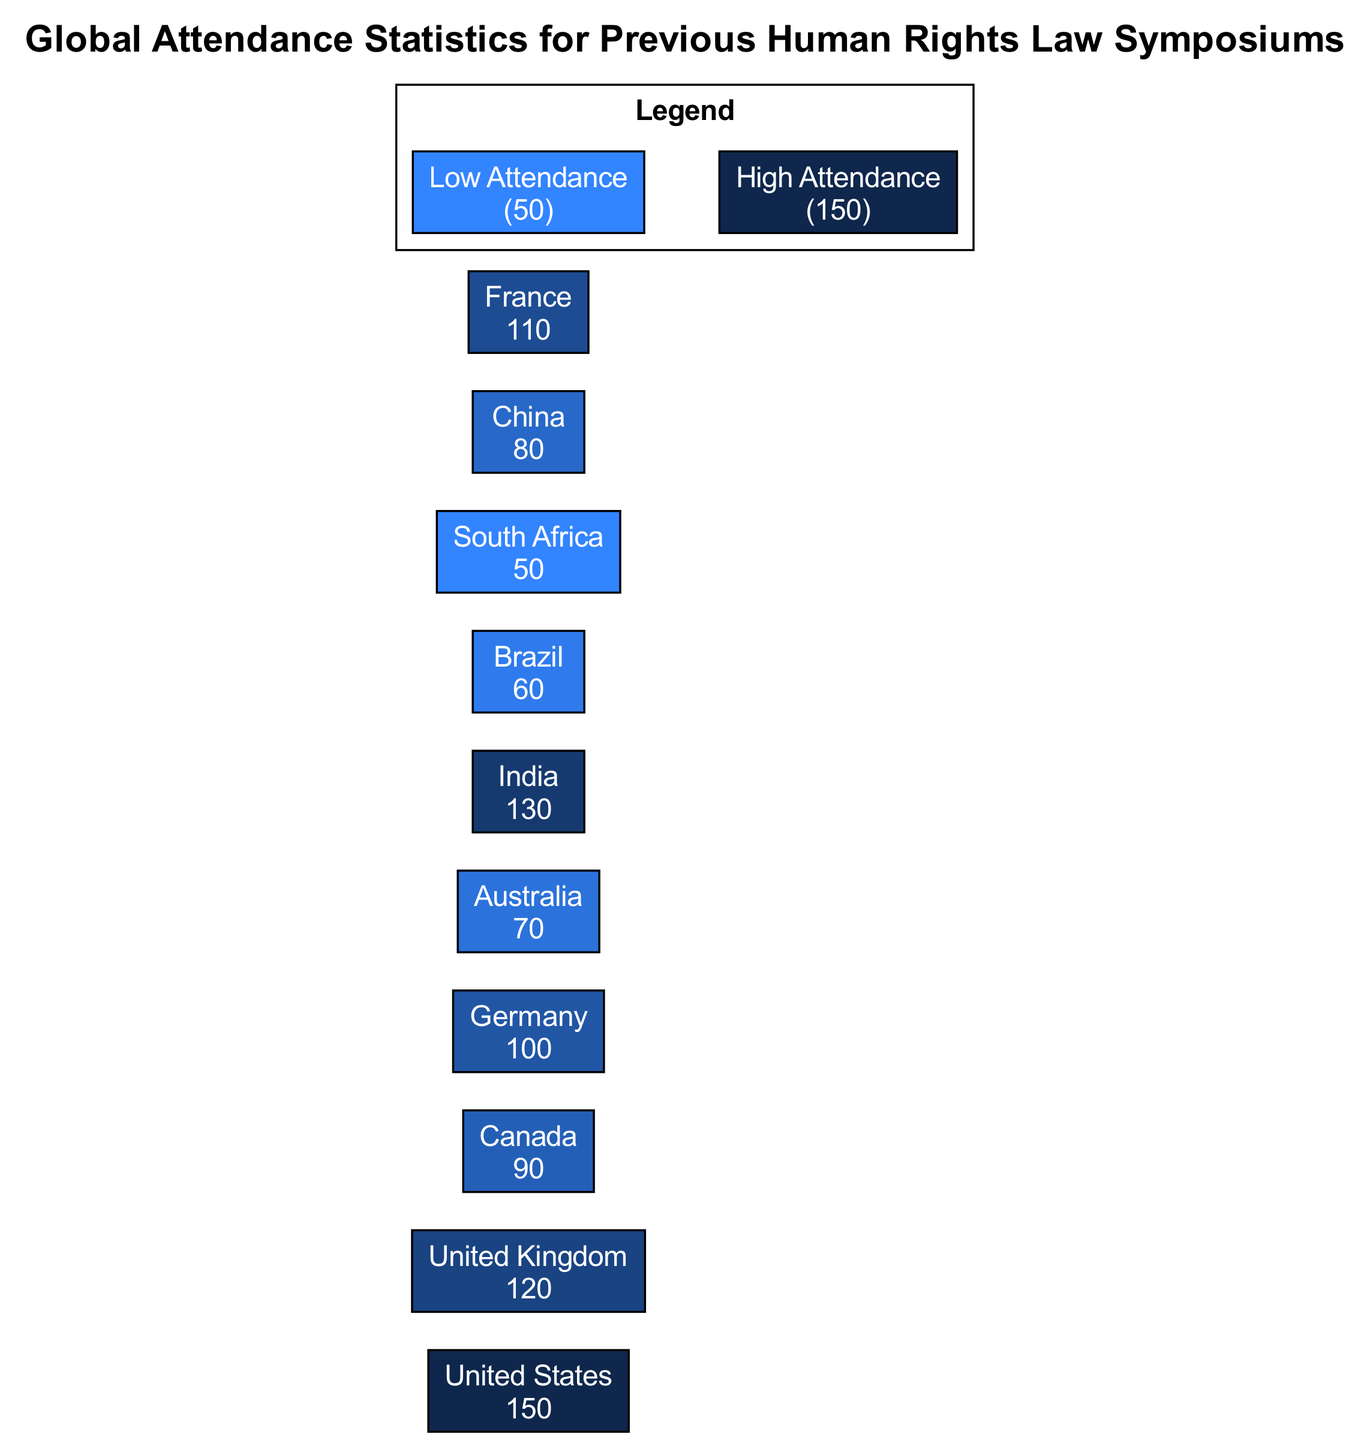What country has the highest attendance at the symposium? By checking the nodes in the diagram, I see that the United States has the highest attendance number listed, which is 150.
Answer: United States What is the attendance number for Canada? The node for Canada indicates an attendance of 90 participants at the symposium.
Answer: 90 How many countries are represented in the diagram? I can count the nodes listed in the diagram, which shows a total of 10 different countries represented.
Answer: 10 Which country has an attendance figure closest to South Africa? By comparing the attendance numbers of the nodes, I see South Africa has 50 and Brazil has the next closest figure at 60.
Answer: Brazil Is the attendance for India higher or lower than that of France? Evaluating the attendance numbers shows India has 130 and France has 110; therefore, India's attendance is higher.
Answer: Higher What color represents the country with the lowest attendance? Looking at the color of South Africa's node, which has the lowest attendance at 50, it is colored in a light blue shade.
Answer: Light blue What is the minimum attendance represented in the diagram? The notes section of the diagram specifies that the minimum attendance listed is 50.
Answer: 50 How many participants attended from the United Kingdom compared to Australia? The United Kingdom has 120 participants while Australia has 70; 120 is greater than 70.
Answer: 120 Which country has the second highest attendance? By comparing the attendance numbers for each country, India ranks second with 130, after the United States.
Answer: India 